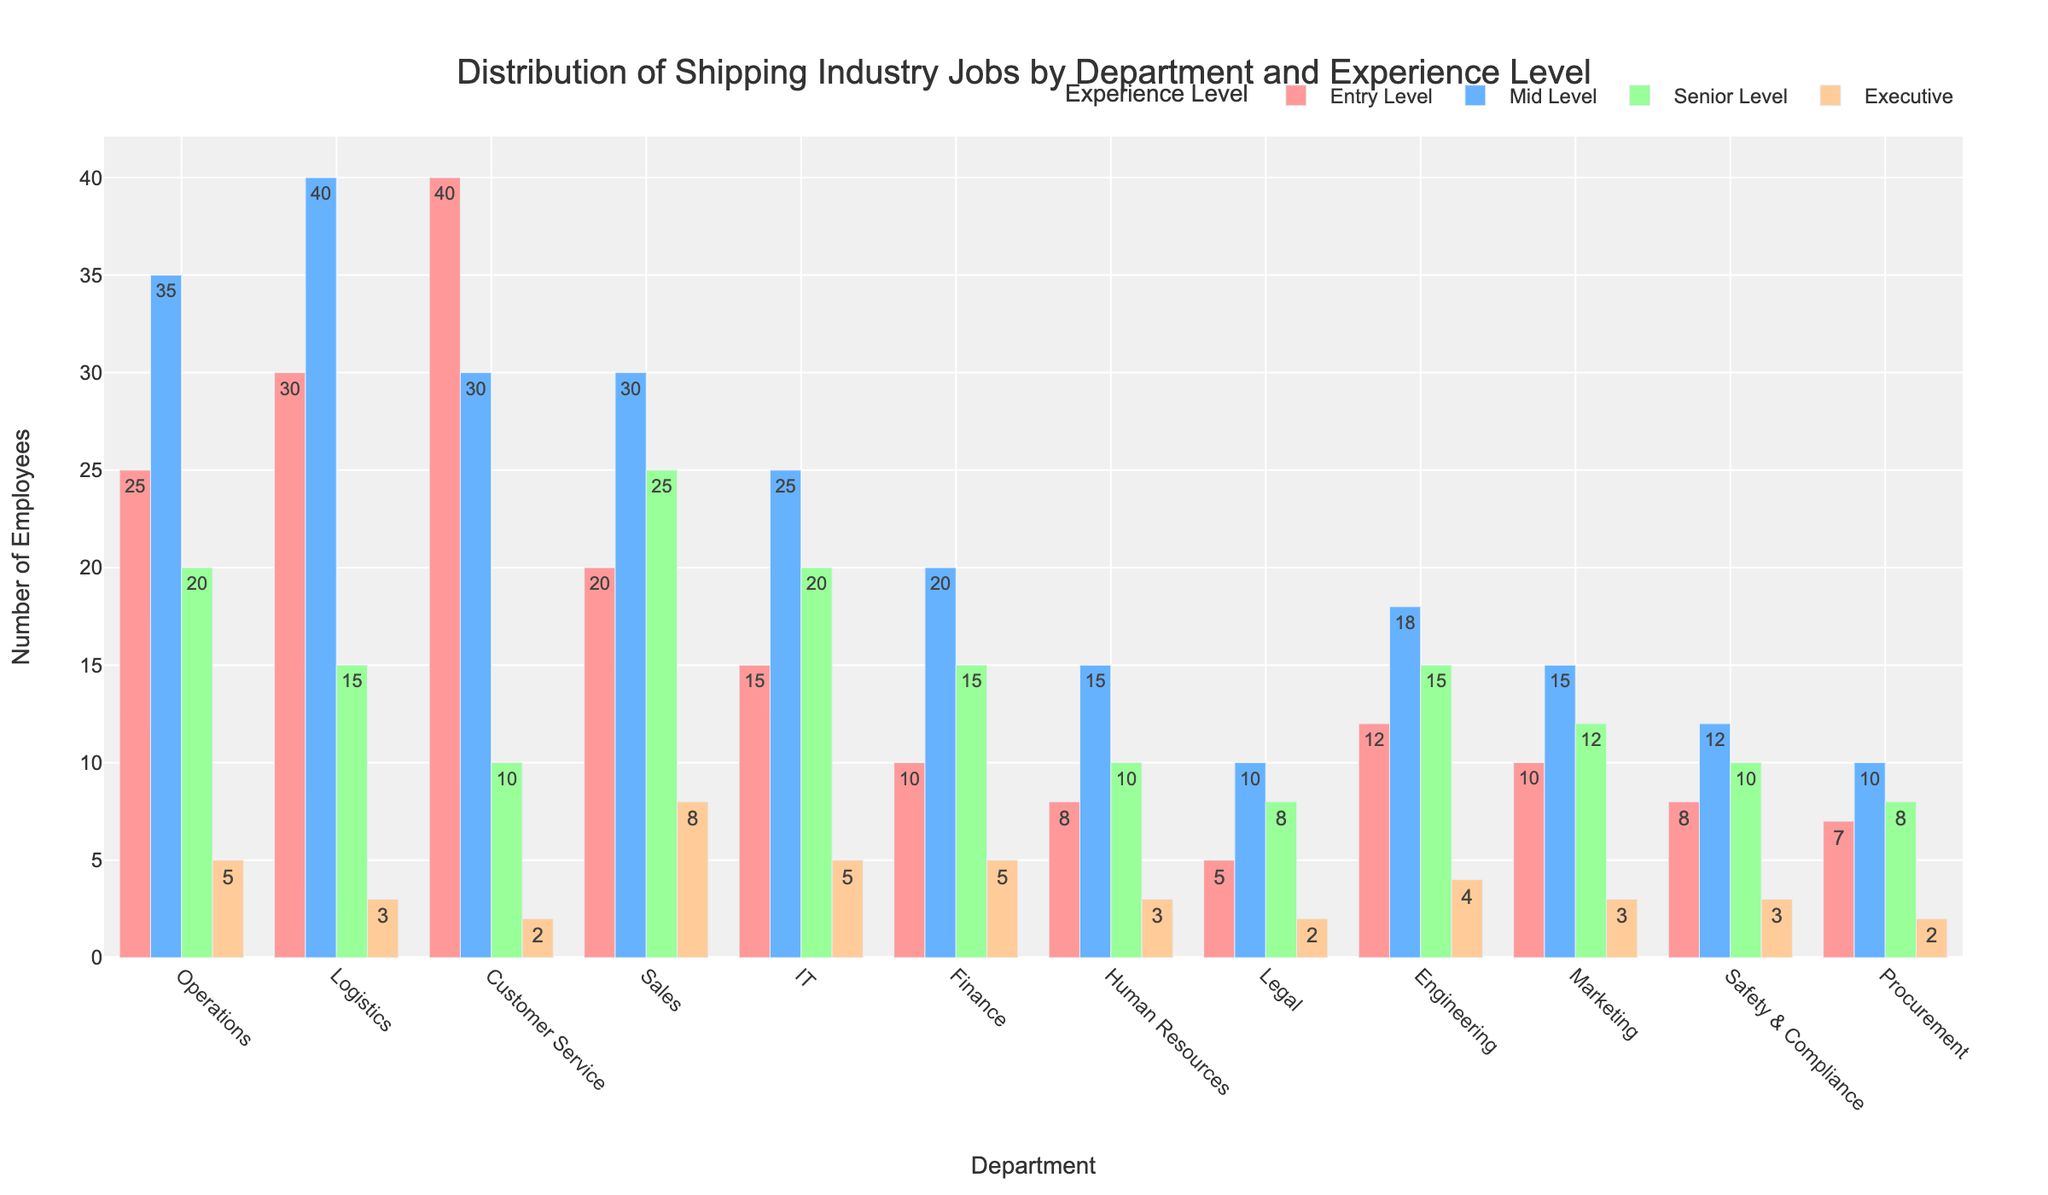What is the department with the most entry-level employees? By looking at the height of the bars representing entry-level employees, we can see that the Customer Service department has the highest bar.
Answer: Customer Service Which department has the highest number of senior-level employees? By comparing the heights of all bars categorized under "Senior Level," we can see that the Sales department has the tallest bar for senior-level employees.
Answer: Sales What is the total number of executive-level employees in the Operations and Logistics departments? The Operations department has 5 executive-level employees, and the Logistics department has 3 executive-level employees. The sum of these two numbers is 5 + 3 = 8.
Answer: 8 In which department is the difference between entry-level and mid-level employees the greatest? The difference between entry-level (30) and mid-level (40) is 10 for Logistics. For Customer Service, the difference is 40 - 30 = 10. For Operations, it's 35 - 25 = 10. Sales, IT, and Finance have differences less than 10. So, the maximum difference of 10 occurs in both Logistics, Customer Service, and Operations.
Answer: Logistics, Customer Service, Operations What is the average number of employees in the IT department across all experience levels? The IT department has 15 (Entry Level) + 25 (Mid Level) + 20 (Senior Level) + 5 (Executive) = 65 employees in total. There are 4 experience levels, so the average number of employees is 65 / 4 = 16.25.
Answer: 16.25 Which two departments have the closest number of mid-level employees? By examining the bars for mid-level employees, IT has 25 mid-level employees and Sales has 30, with a difference of 5. However, HR has 15 mid-level employees and Marketing also has 15, with a difference of 0, which is the smallest difference.
Answer: Human Resources, Marketing How many more entry-level employees are there in Customer Service compared to Finance? Customer Service has 40 entry-level employees, while Finance has 10. The difference is 40 - 10 = 30.
Answer: 30 In which department does the number of senior-level employees exceed the number of entry-level employees? In Sales, the number of senior-level employees (25) is greater than the number of entry-level employees (20). No other department has this characteristic.
Answer: Sales 